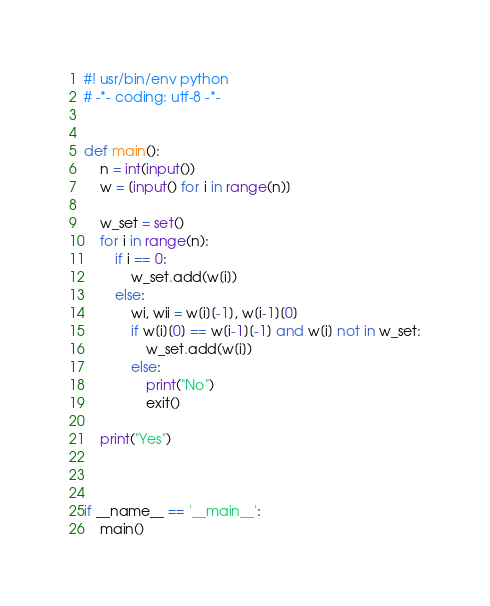Convert code to text. <code><loc_0><loc_0><loc_500><loc_500><_Python_>#! usr/bin/env python
# -*- coding: utf-8 -*-


def main():
    n = int(input())
    w = [input() for i in range(n)]

    w_set = set()
    for i in range(n):
        if i == 0:
            w_set.add(w[i])
        else:
            wi, wii = w[i][-1], w[i-1][0]
            if w[i][0] == w[i-1][-1] and w[i] not in w_set:
                w_set.add(w[i])
            else:
                print("No")
                exit()

    print("Yes")



if __name__ == '__main__':
    main()
</code> 